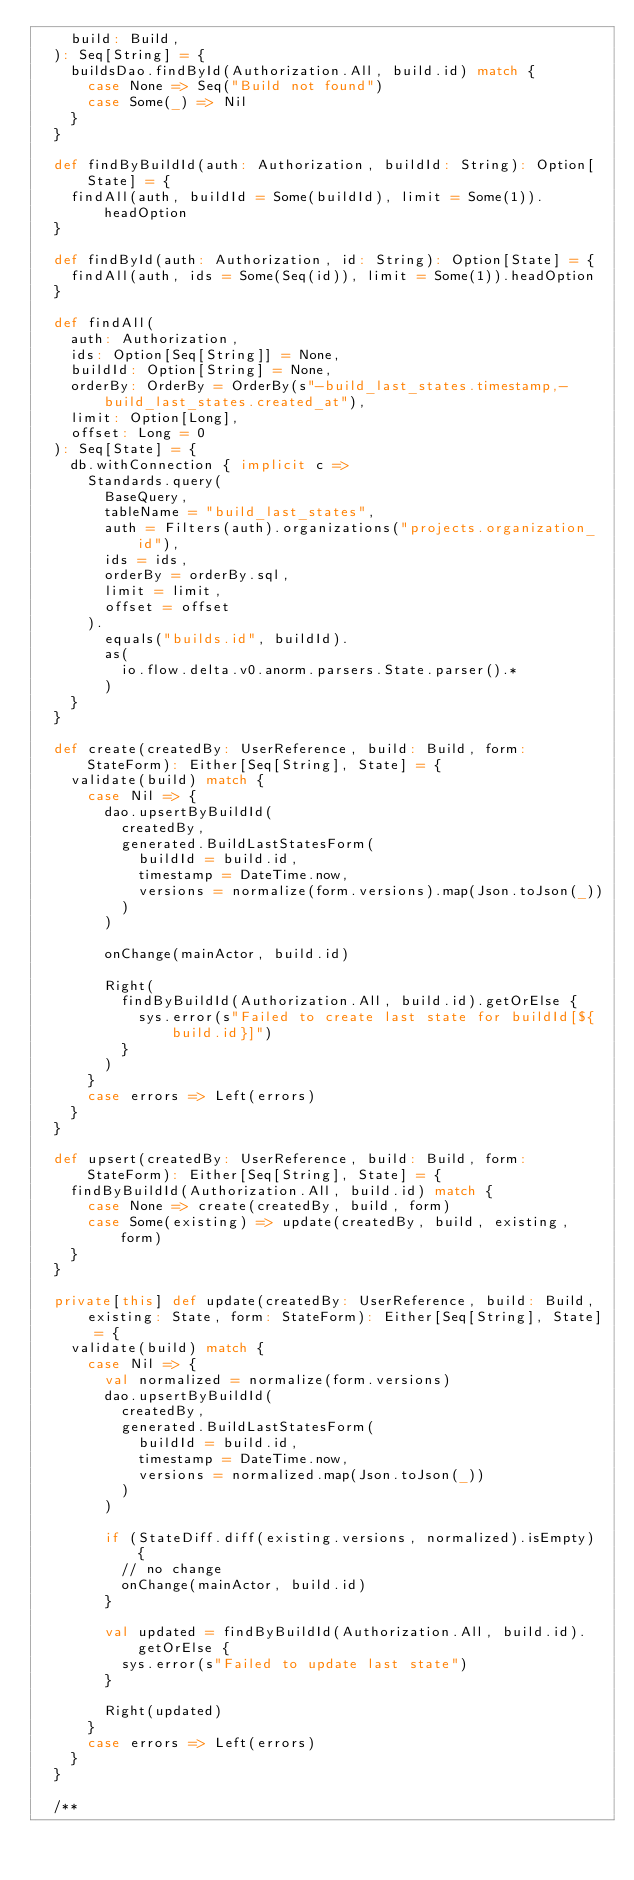<code> <loc_0><loc_0><loc_500><loc_500><_Scala_>    build: Build,
  ): Seq[String] = {
    buildsDao.findById(Authorization.All, build.id) match {
      case None => Seq("Build not found")
      case Some(_) => Nil
    }
  }

  def findByBuildId(auth: Authorization, buildId: String): Option[State] = {
    findAll(auth, buildId = Some(buildId), limit = Some(1)).headOption
  }

  def findById(auth: Authorization, id: String): Option[State] = {
    findAll(auth, ids = Some(Seq(id)), limit = Some(1)).headOption
  }

  def findAll(
    auth: Authorization,
    ids: Option[Seq[String]] = None,
    buildId: Option[String] = None,
    orderBy: OrderBy = OrderBy(s"-build_last_states.timestamp,-build_last_states.created_at"),
    limit: Option[Long],
    offset: Long = 0
  ): Seq[State] = {
    db.withConnection { implicit c =>
      Standards.query(
        BaseQuery,
        tableName = "build_last_states",
        auth = Filters(auth).organizations("projects.organization_id"),
        ids = ids,
        orderBy = orderBy.sql,
        limit = limit,
        offset = offset
      ).
        equals("builds.id", buildId).
        as(
          io.flow.delta.v0.anorm.parsers.State.parser().*
        )
    }
  }

  def create(createdBy: UserReference, build: Build, form: StateForm): Either[Seq[String], State] = {
    validate(build) match {
      case Nil => {
        dao.upsertByBuildId(
          createdBy,
          generated.BuildLastStatesForm(
            buildId = build.id,
            timestamp = DateTime.now,
            versions = normalize(form.versions).map(Json.toJson(_))
          )
        )

        onChange(mainActor, build.id)

        Right(
          findByBuildId(Authorization.All, build.id).getOrElse {
            sys.error(s"Failed to create last state for buildId[${build.id}]")
          }
        )
      }
      case errors => Left(errors)
    }
  }

  def upsert(createdBy: UserReference, build: Build, form: StateForm): Either[Seq[String], State] = {
    findByBuildId(Authorization.All, build.id) match {
      case None => create(createdBy, build, form)
      case Some(existing) => update(createdBy, build, existing, form)
    }
  }

  private[this] def update(createdBy: UserReference, build: Build, existing: State, form: StateForm): Either[Seq[String], State] = {
    validate(build) match {
      case Nil => {
        val normalized = normalize(form.versions)
        dao.upsertByBuildId(
          createdBy,
          generated.BuildLastStatesForm(
            buildId = build.id,
            timestamp = DateTime.now,
            versions = normalized.map(Json.toJson(_))
          )
        )

        if (StateDiff.diff(existing.versions, normalized).isEmpty) {
          // no change
          onChange(mainActor, build.id)
        }

        val updated = findByBuildId(Authorization.All, build.id).getOrElse {
          sys.error(s"Failed to update last state")
        }

        Right(updated)
      }
      case errors => Left(errors)
    }
  }

  /**</code> 